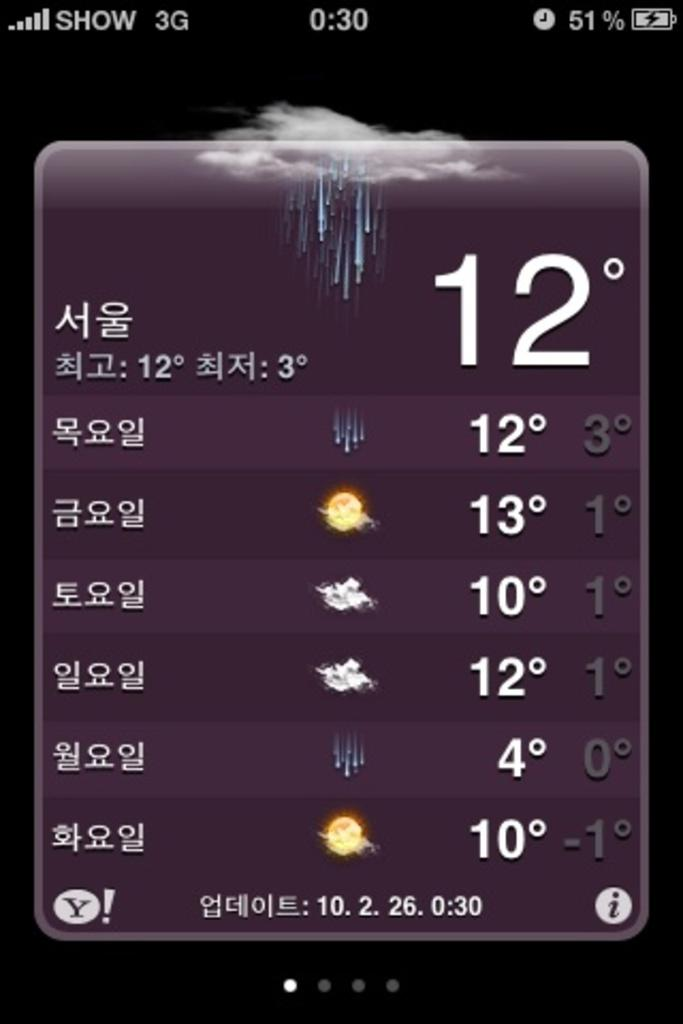<image>
Offer a succinct explanation of the picture presented. a weather app with the temps between 4 and 12 degrees 